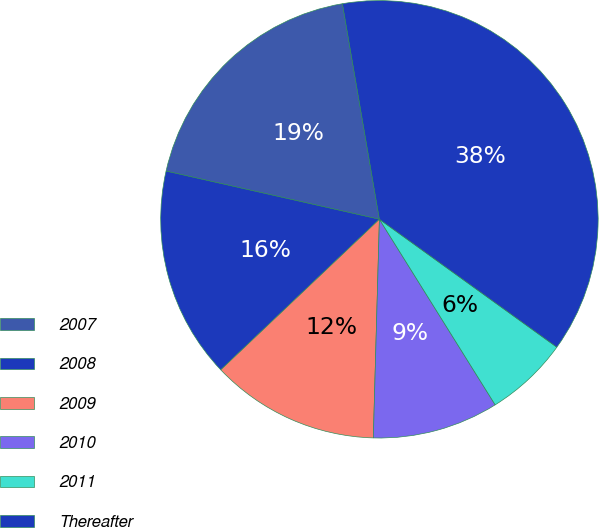Convert chart. <chart><loc_0><loc_0><loc_500><loc_500><pie_chart><fcel>2007<fcel>2008<fcel>2009<fcel>2010<fcel>2011<fcel>Thereafter<nl><fcel>18.76%<fcel>15.62%<fcel>12.47%<fcel>9.32%<fcel>6.18%<fcel>37.64%<nl></chart> 